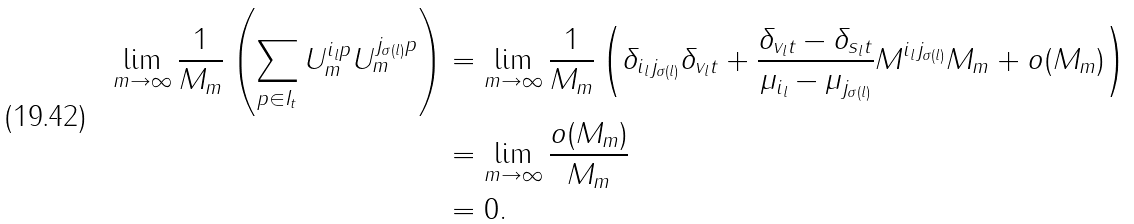<formula> <loc_0><loc_0><loc_500><loc_500>\lim _ { m \rightarrow \infty } \frac { 1 } { \| M _ { m } \| } \left ( \sum _ { p \in I _ { t } } U ^ { i _ { l } p } _ { m } U ^ { j _ { \sigma ( l ) } p } _ { m } \right ) & = \lim _ { m \rightarrow \infty } \frac { 1 } { \| M _ { m } \| } \left ( \delta _ { i _ { l } j _ { \sigma ( l ) } } \delta _ { v _ { l } t } + \frac { \delta _ { v _ { l } t } - \delta _ { s _ { l } t } } { \mu _ { i _ { l } } - \mu _ { j _ { \sigma ( l ) } } } M ^ { i _ { l } j _ { \sigma ( l ) } } \| M _ { m } \| + o ( \| M _ { m } \| ) \right ) \\ & = \lim _ { m \rightarrow \infty } \frac { o ( \| M _ { m } \| ) } { \| M _ { m } \| } \\ & = 0 .</formula> 